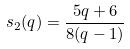Convert formula to latex. <formula><loc_0><loc_0><loc_500><loc_500>s _ { 2 } ( q ) = \frac { 5 q + 6 } { 8 ( q - 1 ) }</formula> 